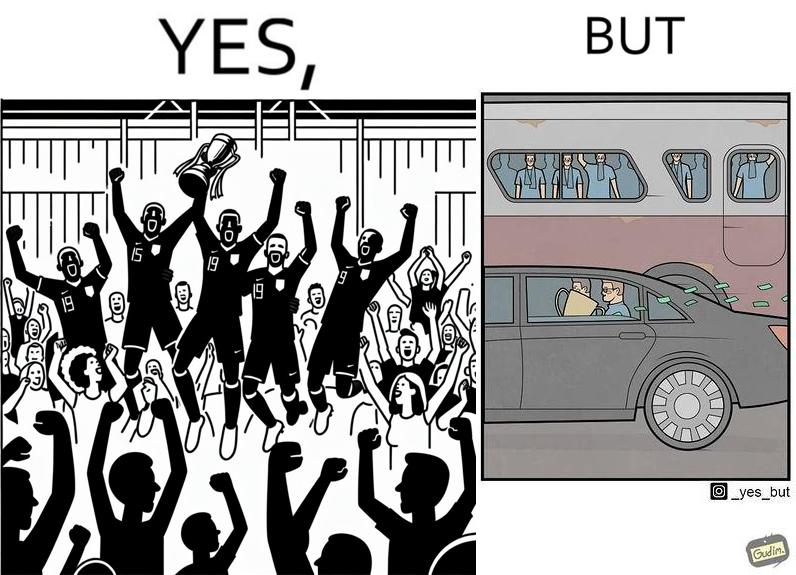Is this image satirical or non-satirical? Yes, this image is satirical. 